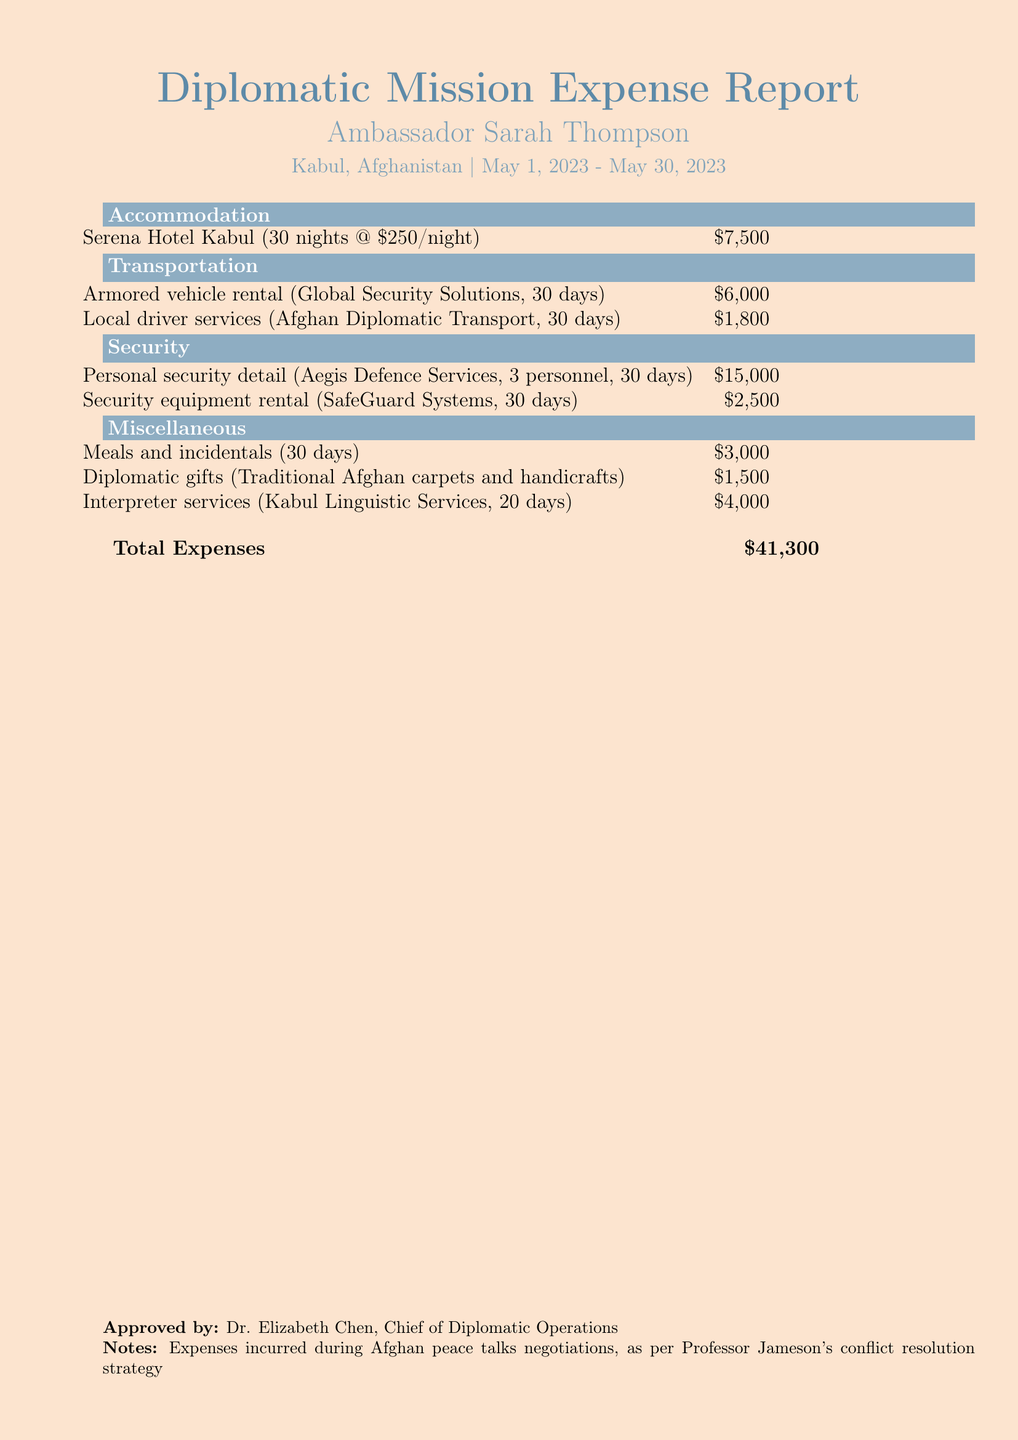What is the total expense for the diplomatic mission? The total expense is listed at the bottom of the document.
Answer: $41,300 How many nights did the ambassador stay at the hotel? The accommodation section specifies that the ambassador stayed for 30 nights.
Answer: 30 nights What was the daily rate for the hotel? The accommodation costs state the hotel rate is $250 per night.
Answer: $250 Who approved the expense report? The document includes a name under the "Approved by" section.
Answer: Dr. Elizabeth Chen What was the cost for meals and incidentals? The miscellaneous section provides the total amount for meals and incidentals.
Answer: $3,000 How many personnel were part of the personal security detail? The security section specifies that there were 3 personnel for security.
Answer: 3 personnel What company provided the armored vehicle rental? The transportation section mentions the specific company that offered this service.
Answer: Global Security Solutions What was the cost for interpreter services? The miscellaneous costs summarize the expense for interpreter services within the document.
Answer: $4,000 What was the total cost for security equipment rental? The security section specifies the total amount for this rental.
Answer: $2,500 